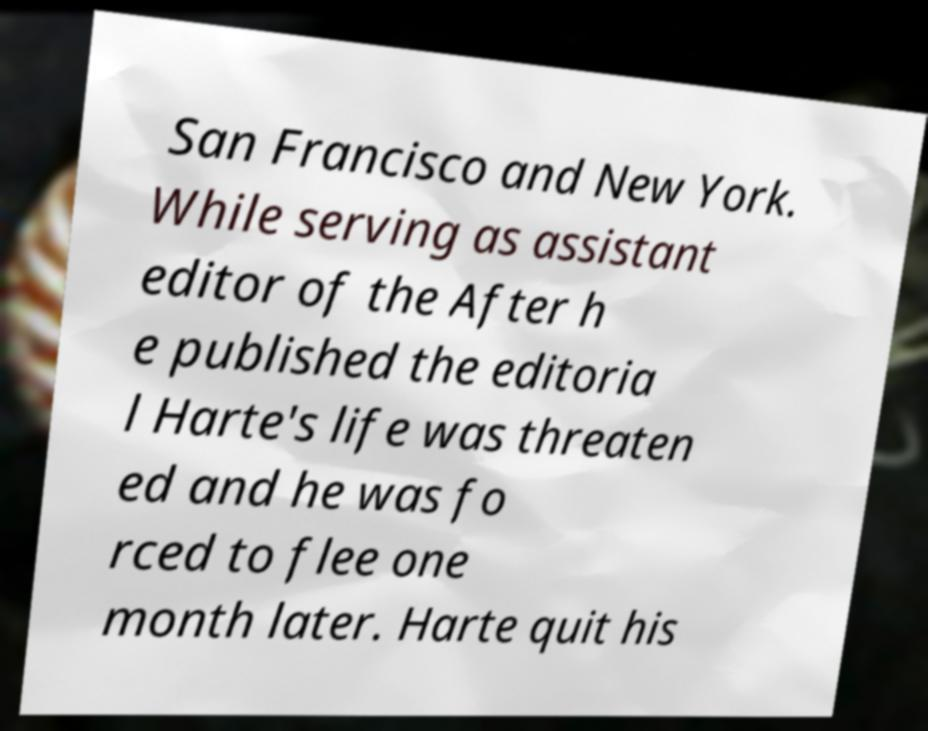I need the written content from this picture converted into text. Can you do that? San Francisco and New York. While serving as assistant editor of the After h e published the editoria l Harte's life was threaten ed and he was fo rced to flee one month later. Harte quit his 